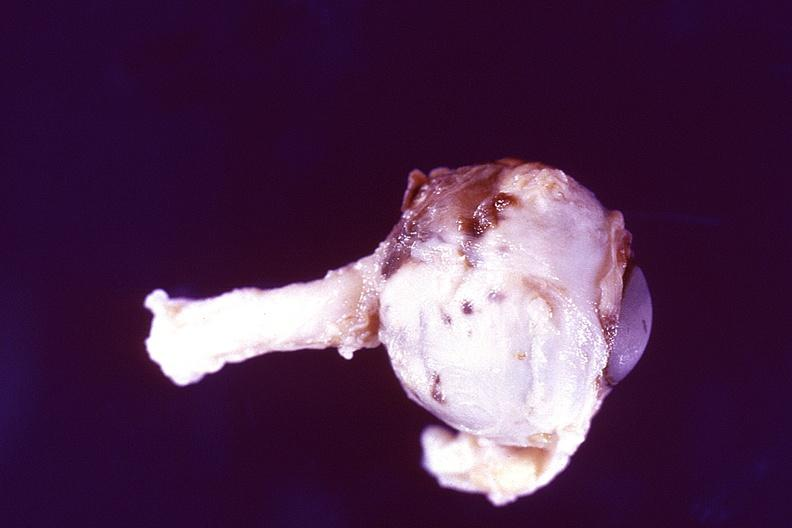s eye present?
Answer the question using a single word or phrase. Yes 